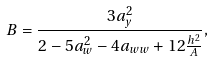Convert formula to latex. <formula><loc_0><loc_0><loc_500><loc_500>B = \frac { 3 a _ { y } ^ { 2 } } { 2 - 5 a _ { w } ^ { 2 } - 4 a _ { w w } + 1 2 \frac { h ^ { 2 } } { A } } ,</formula> 